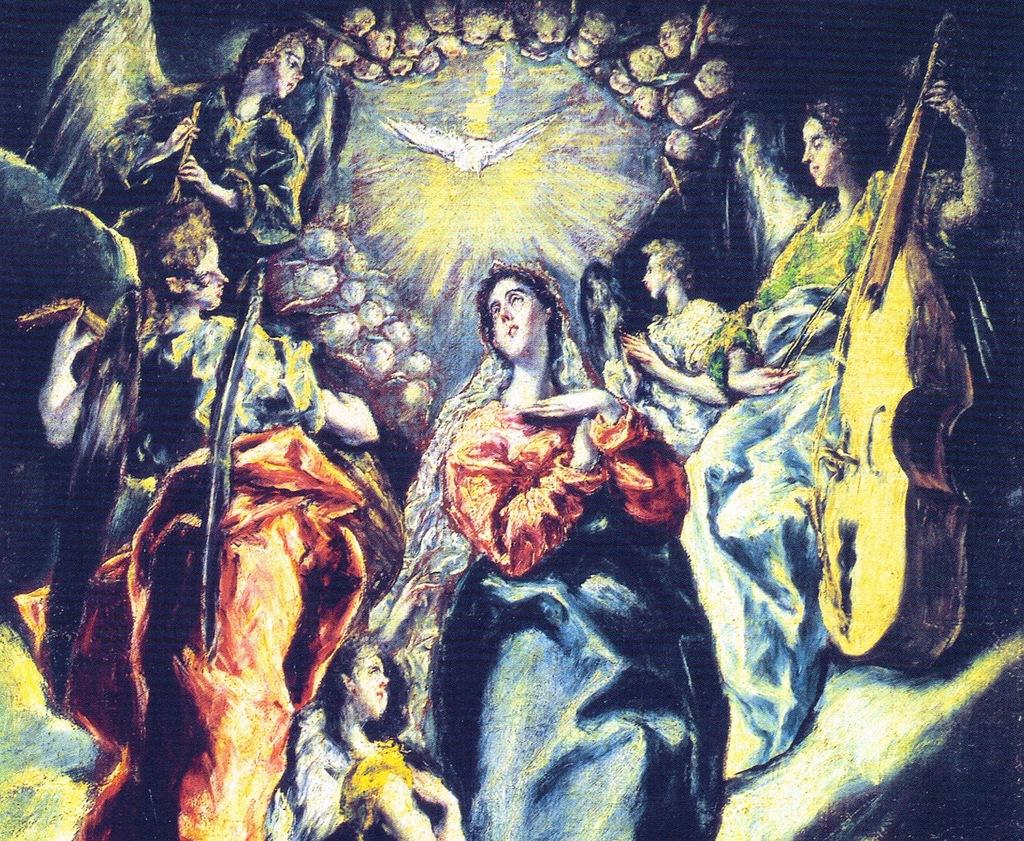What is the main subject of the image? The main subject of the image is a painting. What types of images can be seen in the painting? The painting contains person images and bird images. What type of riddle is depicted in the painting? There is no riddle depicted in the painting; it contains person and bird images. How many beads are present in the painting? There are no beads present in the painting; it contains person and bird images. 